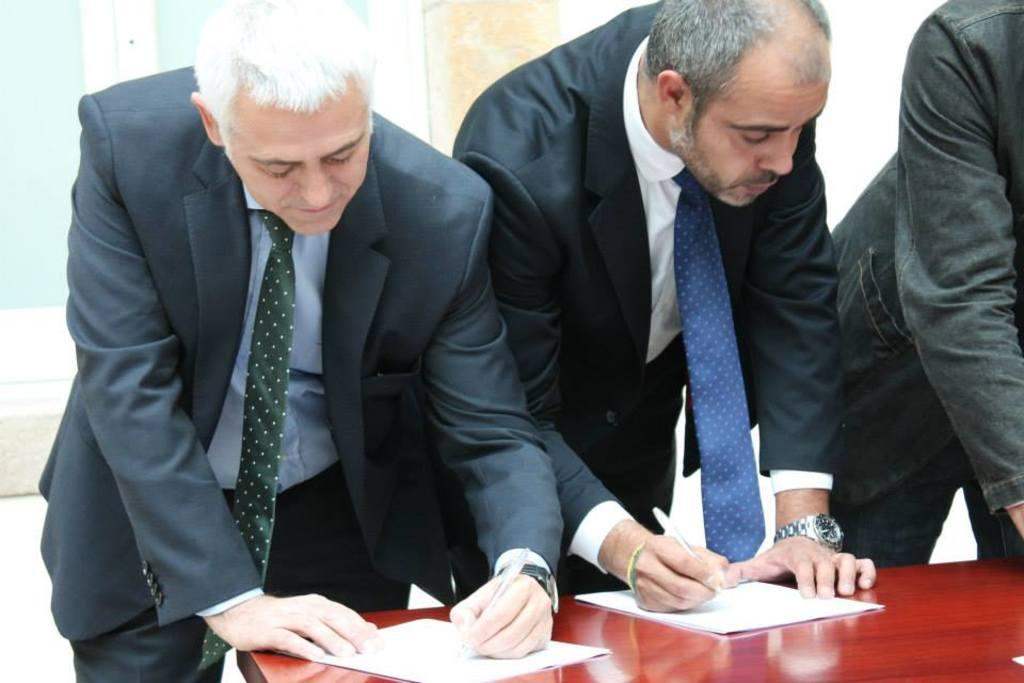How many people are in the image? There are three people in the image. What are the two people wearing? Both of the people are wearing formal dress. What are the two people holding? They are both holding pens. What can be seen on the table in the image? There are papers on the table. What type of glass is being used to serve the wine in the image? There is no glass or wine present in the image. Are any stockings visible on the people in the image? The provided facts do not mention stockings, so we cannot determine if any are visible. 